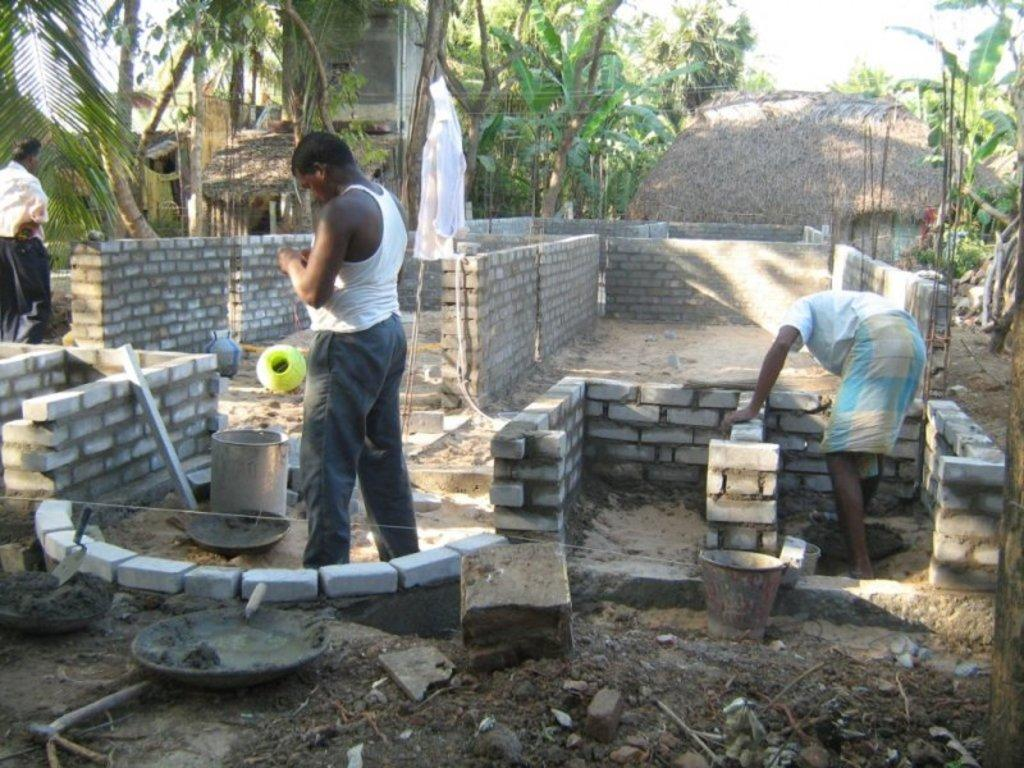How many people are present in the image? There are two persons in the image. What are the persons doing in the image? The persons are constructing walls. What can be seen in the background of the image? There are trees in the background of the image. What material is visible on the left side of the image? Cement is visible on the left side of the image. What type of carriage can be seen in the image? There is no carriage present in the image. What kind of joke is being told by the persons in the image? There is no indication of a joke being told in the image; the persons are focused on constructing walls. 